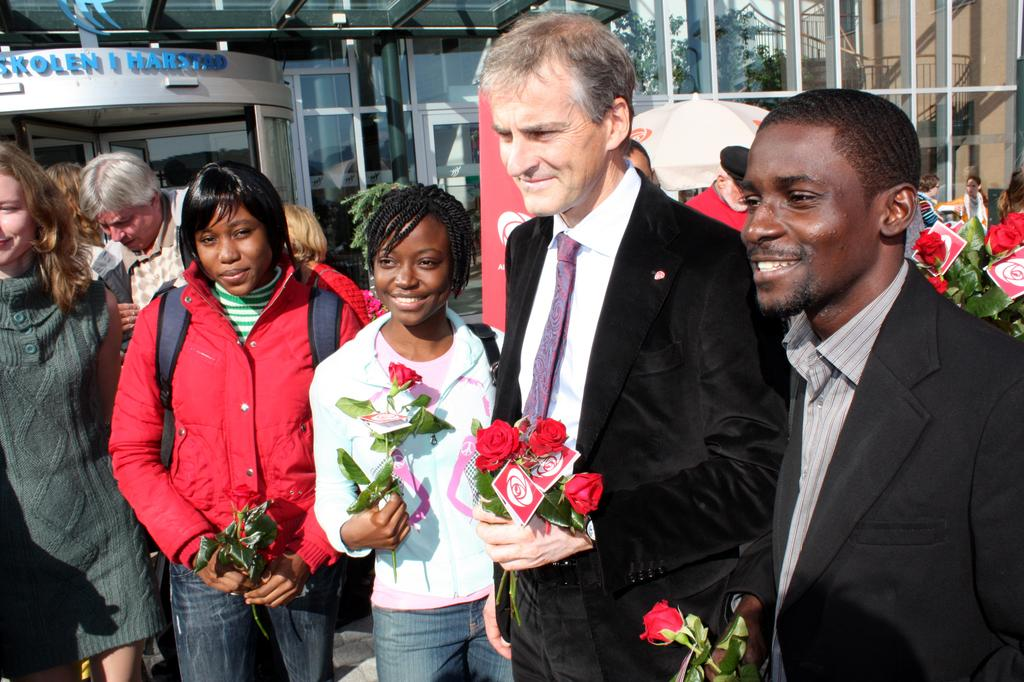What are the people holding in the image? The people are holding red flowers in the image. What structure can be seen in the image? There is a tent in the image. What is hanging or displayed in the image? There is a banner in the image. What can be seen in the distance in the image? There are buildings in the background of the image. What type of skin condition is visible on the people in the image? There is no indication of any skin condition visible on the people in the image. How many days have passed since the event depicted in the image? The image does not provide any information about the time frame or duration of the event. Is the image taken during the night? The image does not provide any information about the time of day, so it cannot be determined if it was taken during the night. 